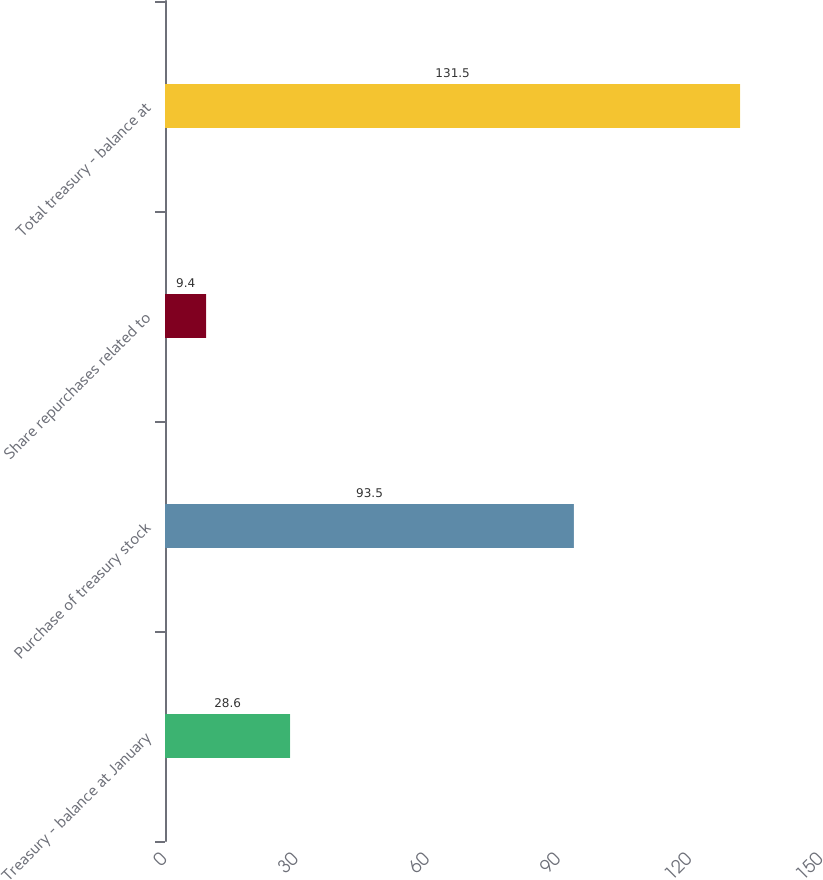Convert chart to OTSL. <chart><loc_0><loc_0><loc_500><loc_500><bar_chart><fcel>Treasury - balance at January<fcel>Purchase of treasury stock<fcel>Share repurchases related to<fcel>Total treasury - balance at<nl><fcel>28.6<fcel>93.5<fcel>9.4<fcel>131.5<nl></chart> 